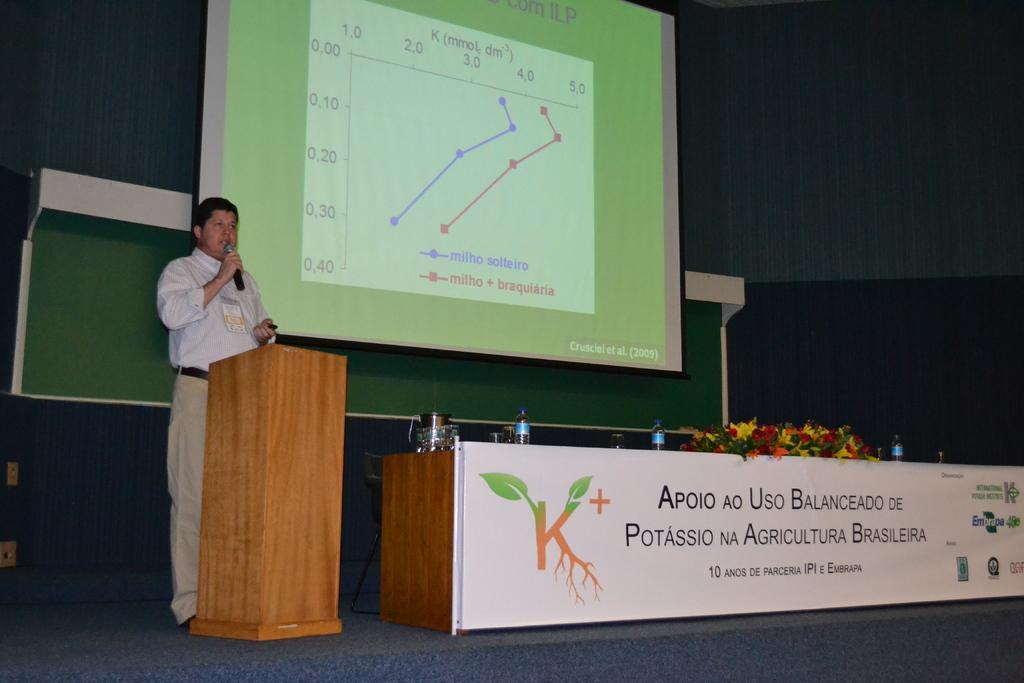Please provide a concise description of this image. This man is holding a mic and in-front of this man there is a podium. This is screen. Table with banner, bottles and flowers. 